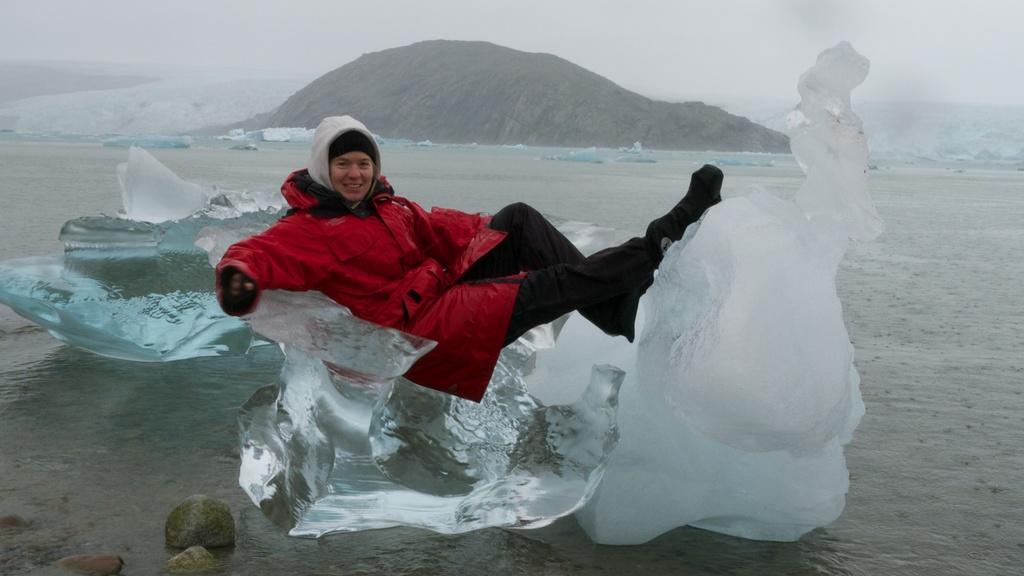Describe this image in one or two sentences. In this image there is a person wearing a red jacket is lying on the ice which is on the land having some water and few rocks on it. Background there are hills. Top of the image there is sky. 